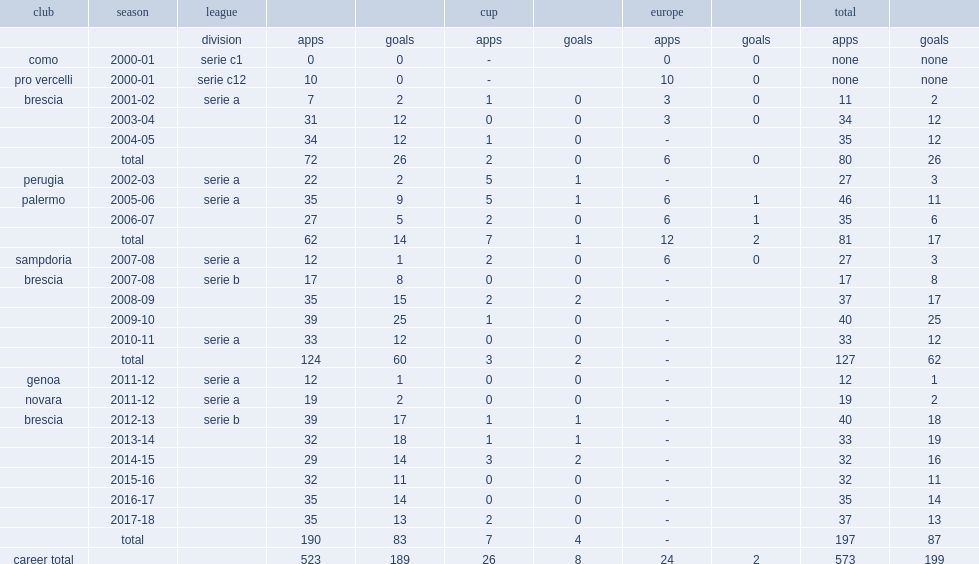Can you parse all the data within this table? {'header': ['club', 'season', 'league', '', '', 'cup', '', 'europe', '', 'total', ''], 'rows': [['', '', 'division', 'apps', 'goals', 'apps', 'goals', 'apps', 'goals', 'apps', 'goals'], ['como', '2000-01', 'serie c1', '0', '0', '-', '', '0', '0', 'none', 'none'], ['pro vercelli', '2000-01', 'serie c12', '10', '0', '-', '', '10', '0', 'none', 'none'], ['brescia', '2001-02', 'serie a', '7', '2', '1', '0', '3', '0', '11', '2'], ['', '2003-04', '', '31', '12', '0', '0', '3', '0', '34', '12'], ['', '2004-05', '', '34', '12', '1', '0', '-', '', '35', '12'], ['', 'total', '', '72', '26', '2', '0', '6', '0', '80', '26'], ['perugia', '2002-03', 'serie a', '22', '2', '5', '1', '-', '', '27', '3'], ['palermo', '2005-06', 'serie a', '35', '9', '5', '1', '6', '1', '46', '11'], ['', '2006-07', '', '27', '5', '2', '0', '6', '1', '35', '6'], ['', 'total', '', '62', '14', '7', '1', '12', '2', '81', '17'], ['sampdoria', '2007-08', 'serie a', '12', '1', '2', '0', '6', '0', '27', '3'], ['brescia', '2007-08', 'serie b', '17', '8', '0', '0', '-', '', '17', '8'], ['', '2008-09', '', '35', '15', '2', '2', '-', '', '37', '17'], ['', '2009-10', '', '39', '25', '1', '0', '-', '', '40', '25'], ['', '2010-11', 'serie a', '33', '12', '0', '0', '-', '', '33', '12'], ['', 'total', '', '124', '60', '3', '2', '-', '', '127', '62'], ['genoa', '2011-12', 'serie a', '12', '1', '0', '0', '-', '', '12', '1'], ['novara', '2011-12', 'serie a', '19', '2', '0', '0', '-', '', '19', '2'], ['brescia', '2012-13', 'serie b', '39', '17', '1', '1', '-', '', '40', '18'], ['', '2013-14', '', '32', '18', '1', '1', '-', '', '33', '19'], ['', '2014-15', '', '29', '14', '3', '2', '-', '', '32', '16'], ['', '2015-16', '', '32', '11', '0', '0', '-', '', '32', '11'], ['', '2016-17', '', '35', '14', '0', '0', '-', '', '35', '14'], ['', '2017-18', '', '35', '13', '2', '0', '-', '', '37', '13'], ['', 'total', '', '190', '83', '7', '4', '-', '', '197', '87'], ['career total', '', '', '523', '189', '26', '8', '24', '2', '573', '199']]} During the 2002-03 season, which league did andrea caracciolo play for perugia, before returning to brescia, scoring 12 goals in the 2003-04 season? Serie a. 